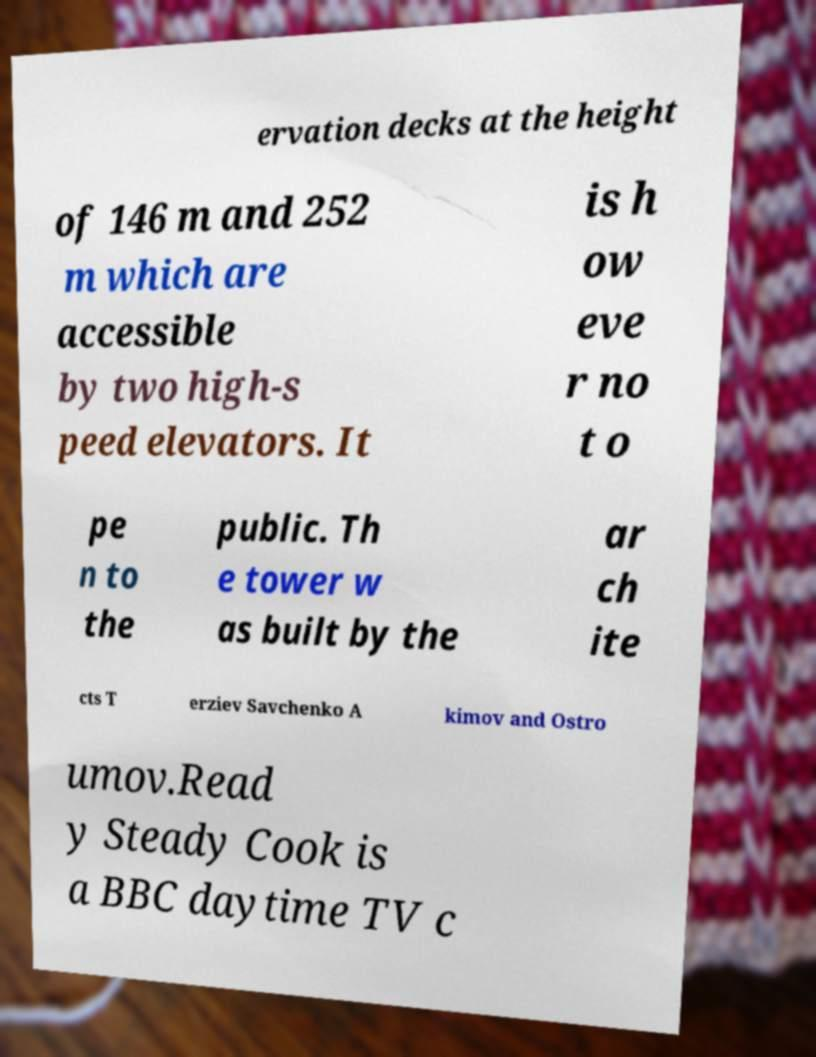Can you accurately transcribe the text from the provided image for me? ervation decks at the height of 146 m and 252 m which are accessible by two high-s peed elevators. It is h ow eve r no t o pe n to the public. Th e tower w as built by the ar ch ite cts T erziev Savchenko A kimov and Ostro umov.Read y Steady Cook is a BBC daytime TV c 